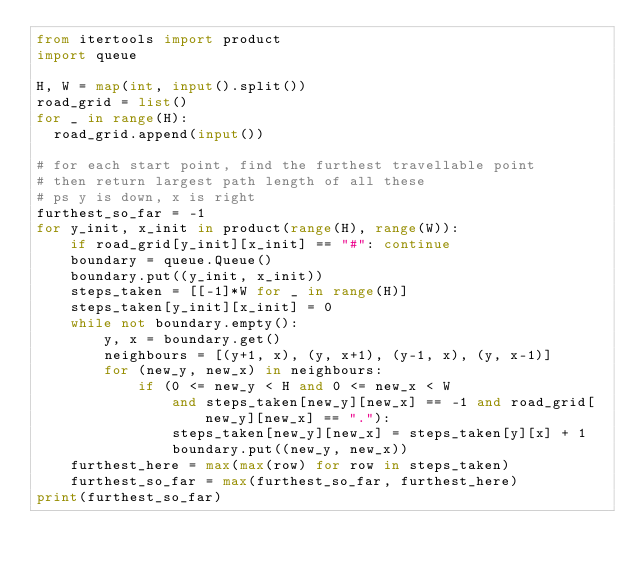<code> <loc_0><loc_0><loc_500><loc_500><_Python_>from itertools import product
import queue
 
H, W = map(int, input().split())
road_grid = list()
for _ in range(H):
  road_grid.append(input())

# for each start point, find the furthest travellable point
# then return largest path length of all these
# ps y is down, x is right
furthest_so_far = -1
for y_init, x_init in product(range(H), range(W)):
    if road_grid[y_init][x_init] == "#": continue
    boundary = queue.Queue()
    boundary.put((y_init, x_init))
    steps_taken = [[-1]*W for _ in range(H)]
    steps_taken[y_init][x_init] = 0
    while not boundary.empty():
        y, x = boundary.get()
        neighbours = [(y+1, x), (y, x+1), (y-1, x), (y, x-1)]
        for (new_y, new_x) in neighbours:
            if (0 <= new_y < H and 0 <= new_x < W
                and steps_taken[new_y][new_x] == -1 and road_grid[new_y][new_x] == "."):
                steps_taken[new_y][new_x] = steps_taken[y][x] + 1
                boundary.put((new_y, new_x))
    furthest_here = max(max(row) for row in steps_taken)
    furthest_so_far = max(furthest_so_far, furthest_here)
print(furthest_so_far)</code> 